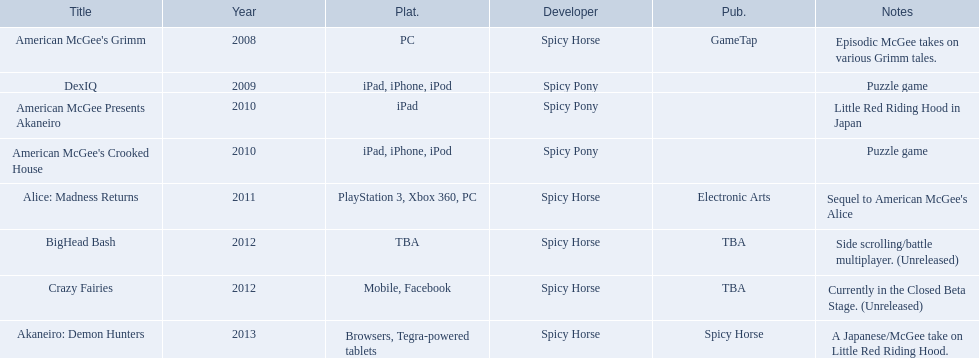What are all of the titles? American McGee's Grimm, DexIQ, American McGee Presents Akaneiro, American McGee's Crooked House, Alice: Madness Returns, BigHead Bash, Crazy Fairies, Akaneiro: Demon Hunters. Who published each title? GameTap, , , , Electronic Arts, TBA, TBA, Spicy Horse. Could you parse the entire table as a dict? {'header': ['Title', 'Year', 'Plat.', 'Developer', 'Pub.', 'Notes'], 'rows': [["American McGee's Grimm", '2008', 'PC', 'Spicy Horse', 'GameTap', 'Episodic McGee takes on various Grimm tales.'], ['DexIQ', '2009', 'iPad, iPhone, iPod', 'Spicy Pony', '', 'Puzzle game'], ['American McGee Presents Akaneiro', '2010', 'iPad', 'Spicy Pony', '', 'Little Red Riding Hood in Japan'], ["American McGee's Crooked House", '2010', 'iPad, iPhone, iPod', 'Spicy Pony', '', 'Puzzle game'], ['Alice: Madness Returns', '2011', 'PlayStation 3, Xbox 360, PC', 'Spicy Horse', 'Electronic Arts', "Sequel to American McGee's Alice"], ['BigHead Bash', '2012', 'TBA', 'Spicy Horse', 'TBA', 'Side scrolling/battle multiplayer. (Unreleased)'], ['Crazy Fairies', '2012', 'Mobile, Facebook', 'Spicy Horse', 'TBA', 'Currently in the Closed Beta Stage. (Unreleased)'], ['Akaneiro: Demon Hunters', '2013', 'Browsers, Tegra-powered tablets', 'Spicy Horse', 'Spicy Horse', 'A Japanese/McGee take on Little Red Riding Hood.']]} Which game was published by electronics arts? Alice: Madness Returns. 